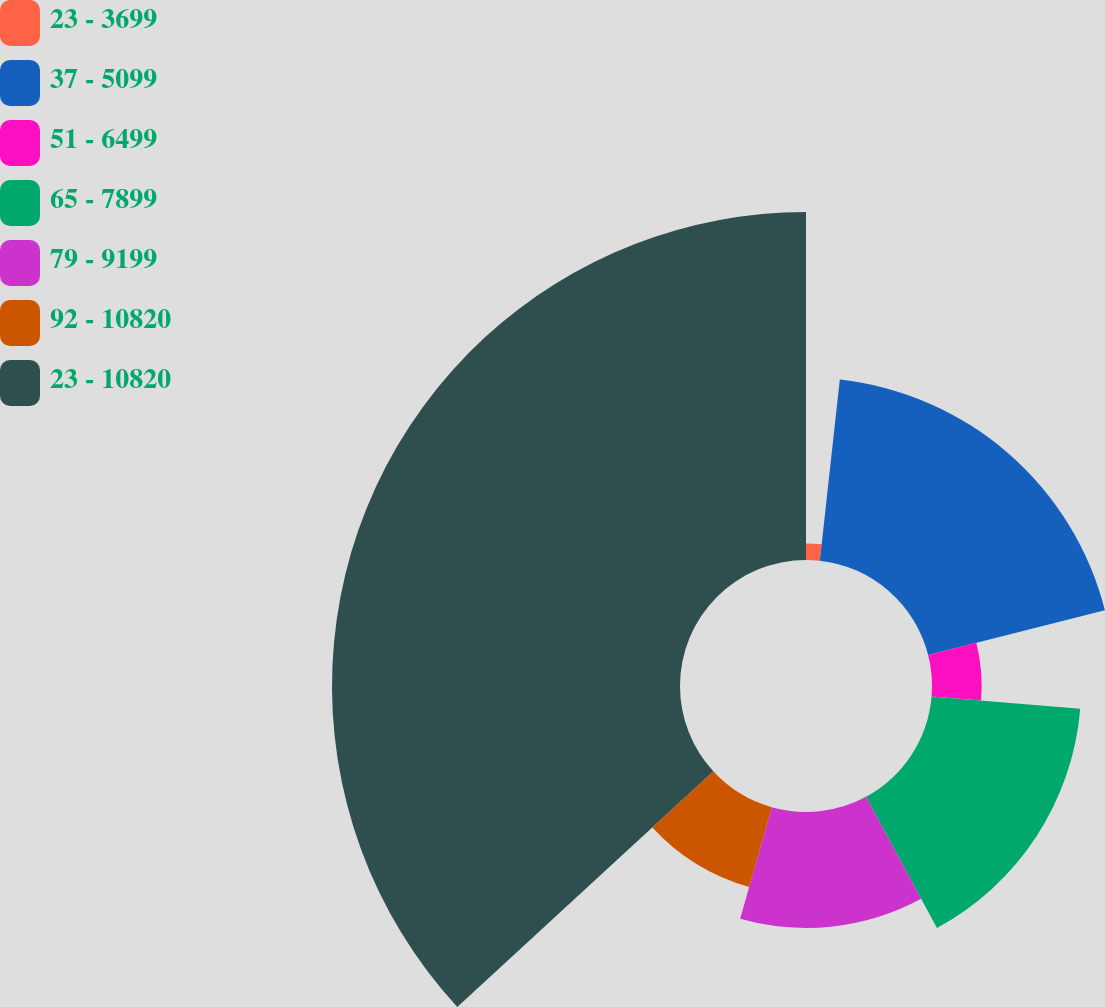Convert chart. <chart><loc_0><loc_0><loc_500><loc_500><pie_chart><fcel>23 - 3699<fcel>37 - 5099<fcel>51 - 6499<fcel>65 - 7899<fcel>79 - 9199<fcel>92 - 10820<fcel>23 - 10820<nl><fcel>1.75%<fcel>19.3%<fcel>5.26%<fcel>15.79%<fcel>12.28%<fcel>8.77%<fcel>36.84%<nl></chart> 